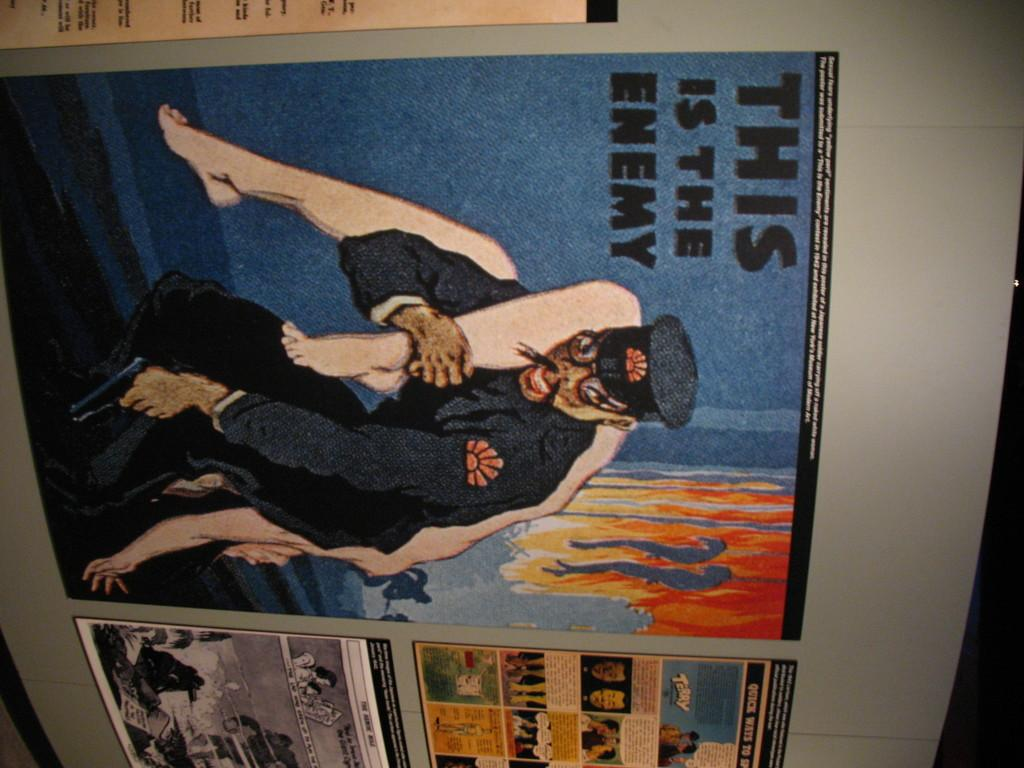<image>
Present a compact description of the photo's key features. Old propaganda poster that says this is the enemy. 